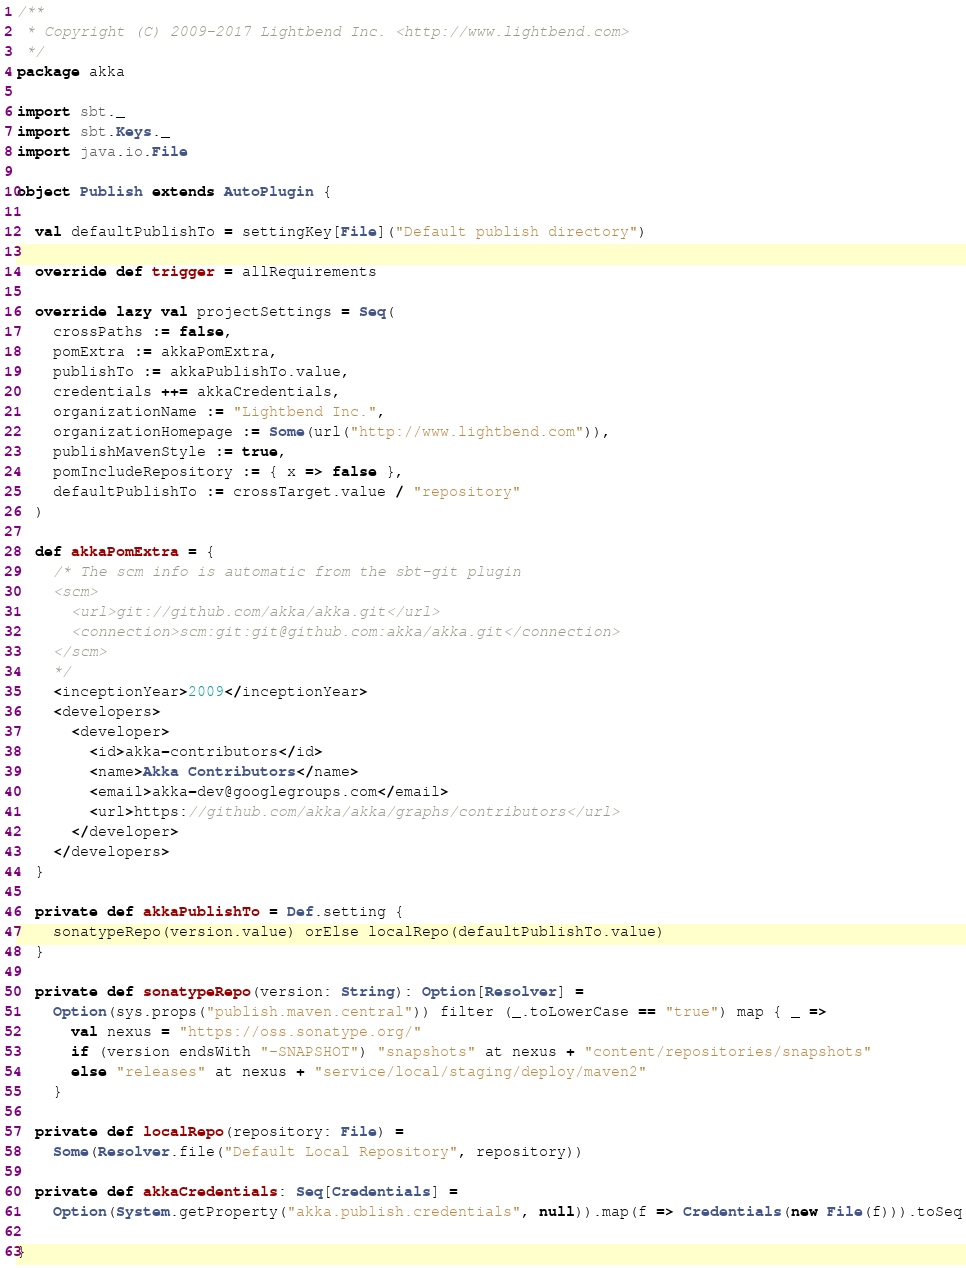<code> <loc_0><loc_0><loc_500><loc_500><_Scala_>/**
 * Copyright (C) 2009-2017 Lightbend Inc. <http://www.lightbend.com>
 */
package akka

import sbt._
import sbt.Keys._
import java.io.File

object Publish extends AutoPlugin {

  val defaultPublishTo = settingKey[File]("Default publish directory")

  override def trigger = allRequirements

  override lazy val projectSettings = Seq(
    crossPaths := false,
    pomExtra := akkaPomExtra,
    publishTo := akkaPublishTo.value,
    credentials ++= akkaCredentials,
    organizationName := "Lightbend Inc.",
    organizationHomepage := Some(url("http://www.lightbend.com")),
    publishMavenStyle := true,
    pomIncludeRepository := { x => false },
    defaultPublishTo := crossTarget.value / "repository"
  )

  def akkaPomExtra = {
    /* The scm info is automatic from the sbt-git plugin
    <scm>
      <url>git://github.com/akka/akka.git</url>
      <connection>scm:git:git@github.com:akka/akka.git</connection>
    </scm>
    */
    <inceptionYear>2009</inceptionYear>
    <developers>
      <developer>
        <id>akka-contributors</id>
        <name>Akka Contributors</name>
        <email>akka-dev@googlegroups.com</email>
        <url>https://github.com/akka/akka/graphs/contributors</url>
      </developer>
    </developers>
  }

  private def akkaPublishTo = Def.setting {
    sonatypeRepo(version.value) orElse localRepo(defaultPublishTo.value)
  }

  private def sonatypeRepo(version: String): Option[Resolver] =
    Option(sys.props("publish.maven.central")) filter (_.toLowerCase == "true") map { _ =>
      val nexus = "https://oss.sonatype.org/"
      if (version endsWith "-SNAPSHOT") "snapshots" at nexus + "content/repositories/snapshots"
      else "releases" at nexus + "service/local/staging/deploy/maven2"
    }

  private def localRepo(repository: File) =
    Some(Resolver.file("Default Local Repository", repository))

  private def akkaCredentials: Seq[Credentials] =
    Option(System.getProperty("akka.publish.credentials", null)).map(f => Credentials(new File(f))).toSeq

}
</code> 